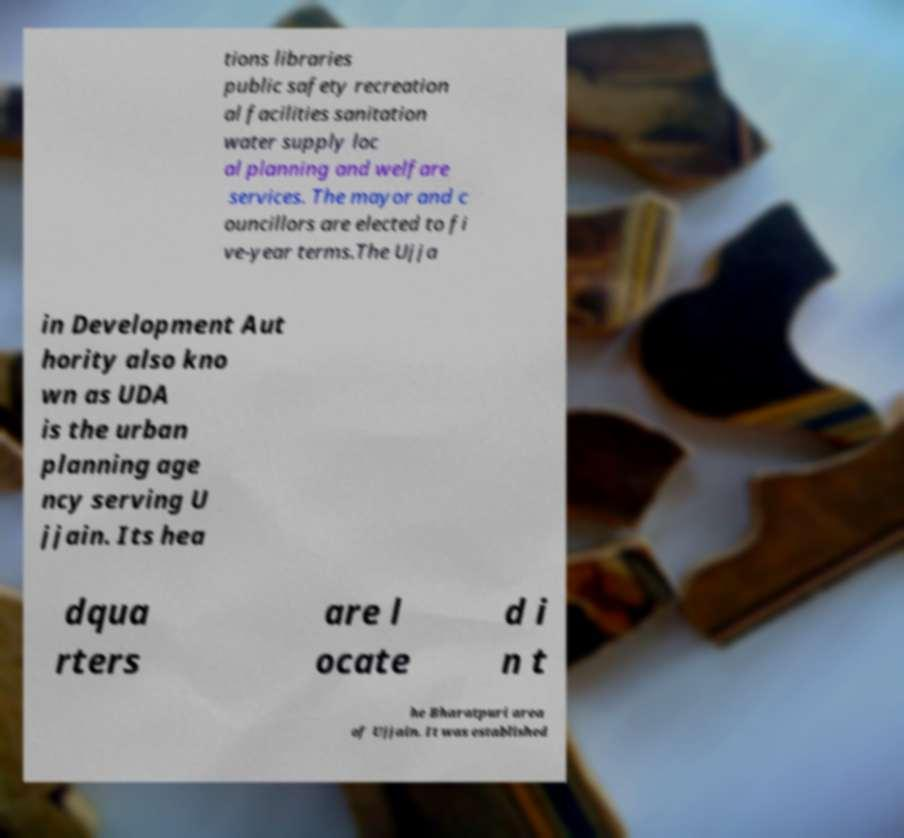There's text embedded in this image that I need extracted. Can you transcribe it verbatim? tions libraries public safety recreation al facilities sanitation water supply loc al planning and welfare services. The mayor and c ouncillors are elected to fi ve-year terms.The Ujja in Development Aut hority also kno wn as UDA is the urban planning age ncy serving U jjain. Its hea dqua rters are l ocate d i n t he Bharatpuri area of Ujjain. It was established 